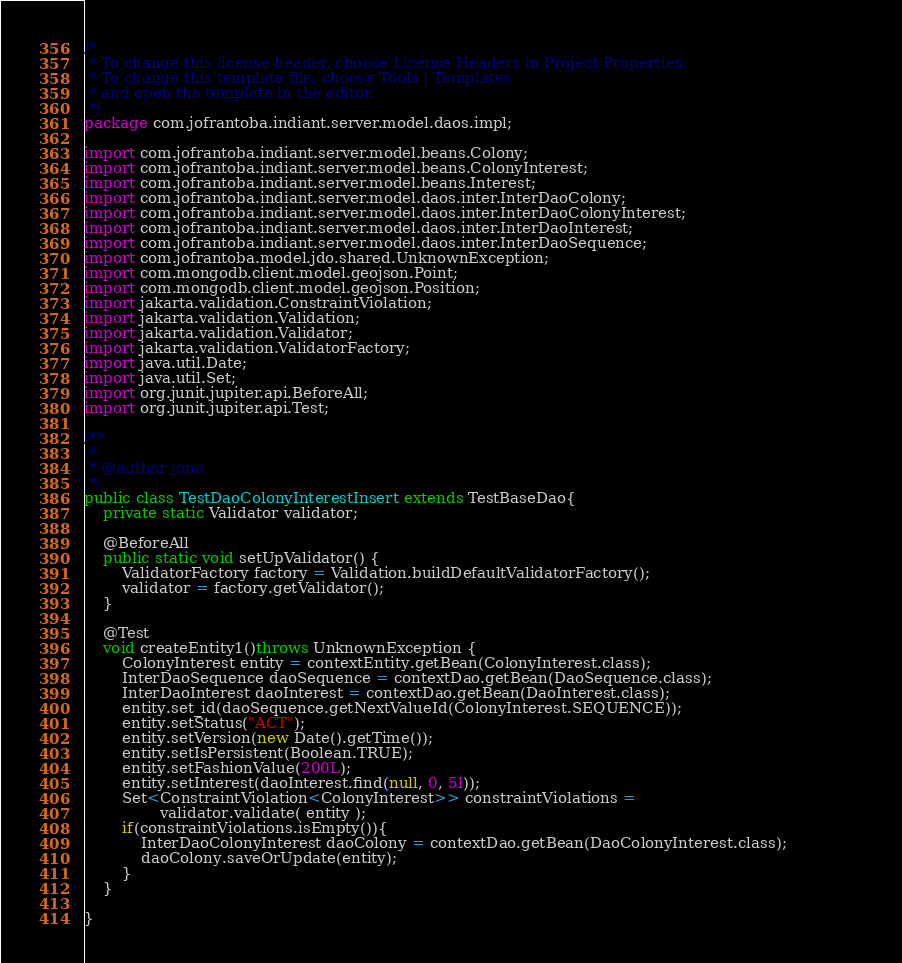<code> <loc_0><loc_0><loc_500><loc_500><_Java_>/*
 * To change this license header, choose License Headers in Project Properties.
 * To change this template file, choose Tools | Templates
 * and open the template in the editor.
 */
package com.jofrantoba.indiant.server.model.daos.impl;

import com.jofrantoba.indiant.server.model.beans.Colony;
import com.jofrantoba.indiant.server.model.beans.ColonyInterest;
import com.jofrantoba.indiant.server.model.beans.Interest;
import com.jofrantoba.indiant.server.model.daos.inter.InterDaoColony;
import com.jofrantoba.indiant.server.model.daos.inter.InterDaoColonyInterest;
import com.jofrantoba.indiant.server.model.daos.inter.InterDaoInterest;
import com.jofrantoba.indiant.server.model.daos.inter.InterDaoSequence;
import com.jofrantoba.model.jdo.shared.UnknownException;
import com.mongodb.client.model.geojson.Point;
import com.mongodb.client.model.geojson.Position;
import jakarta.validation.ConstraintViolation;
import jakarta.validation.Validation;
import jakarta.validation.Validator;
import jakarta.validation.ValidatorFactory;
import java.util.Date;
import java.util.Set;
import org.junit.jupiter.api.BeforeAll;
import org.junit.jupiter.api.Test;

/**
 *
 * @author jona
 */
public class TestDaoColonyInterestInsert extends TestBaseDao{
    private static Validator validator;

    @BeforeAll
    public static void setUpValidator() {
        ValidatorFactory factory = Validation.buildDefaultValidatorFactory();
        validator = factory.getValidator();
    }
    
    @Test
    void createEntity1()throws UnknownException {
        ColonyInterest entity = contextEntity.getBean(ColonyInterest.class);        
        InterDaoSequence daoSequence = contextDao.getBean(DaoSequence.class);
        InterDaoInterest daoInterest = contextDao.getBean(DaoInterest.class);                          
        entity.set_id(daoSequence.getNextValueId(ColonyInterest.SEQUENCE));          
        entity.setStatus("ACT");
        entity.setVersion(new Date().getTime());
        entity.setIsPersistent(Boolean.TRUE);
        entity.setFashionValue(200L);       
        entity.setInterest(daoInterest.find(null, 0, 5l));        
        Set<ConstraintViolation<ColonyInterest>> constraintViolations =
                validator.validate( entity );
        if(constraintViolations.isEmpty()){
            InterDaoColonyInterest daoColony = contextDao.getBean(DaoColonyInterest.class);                
            daoColony.saveOrUpdate(entity);
        }        
    }
    
}
</code> 